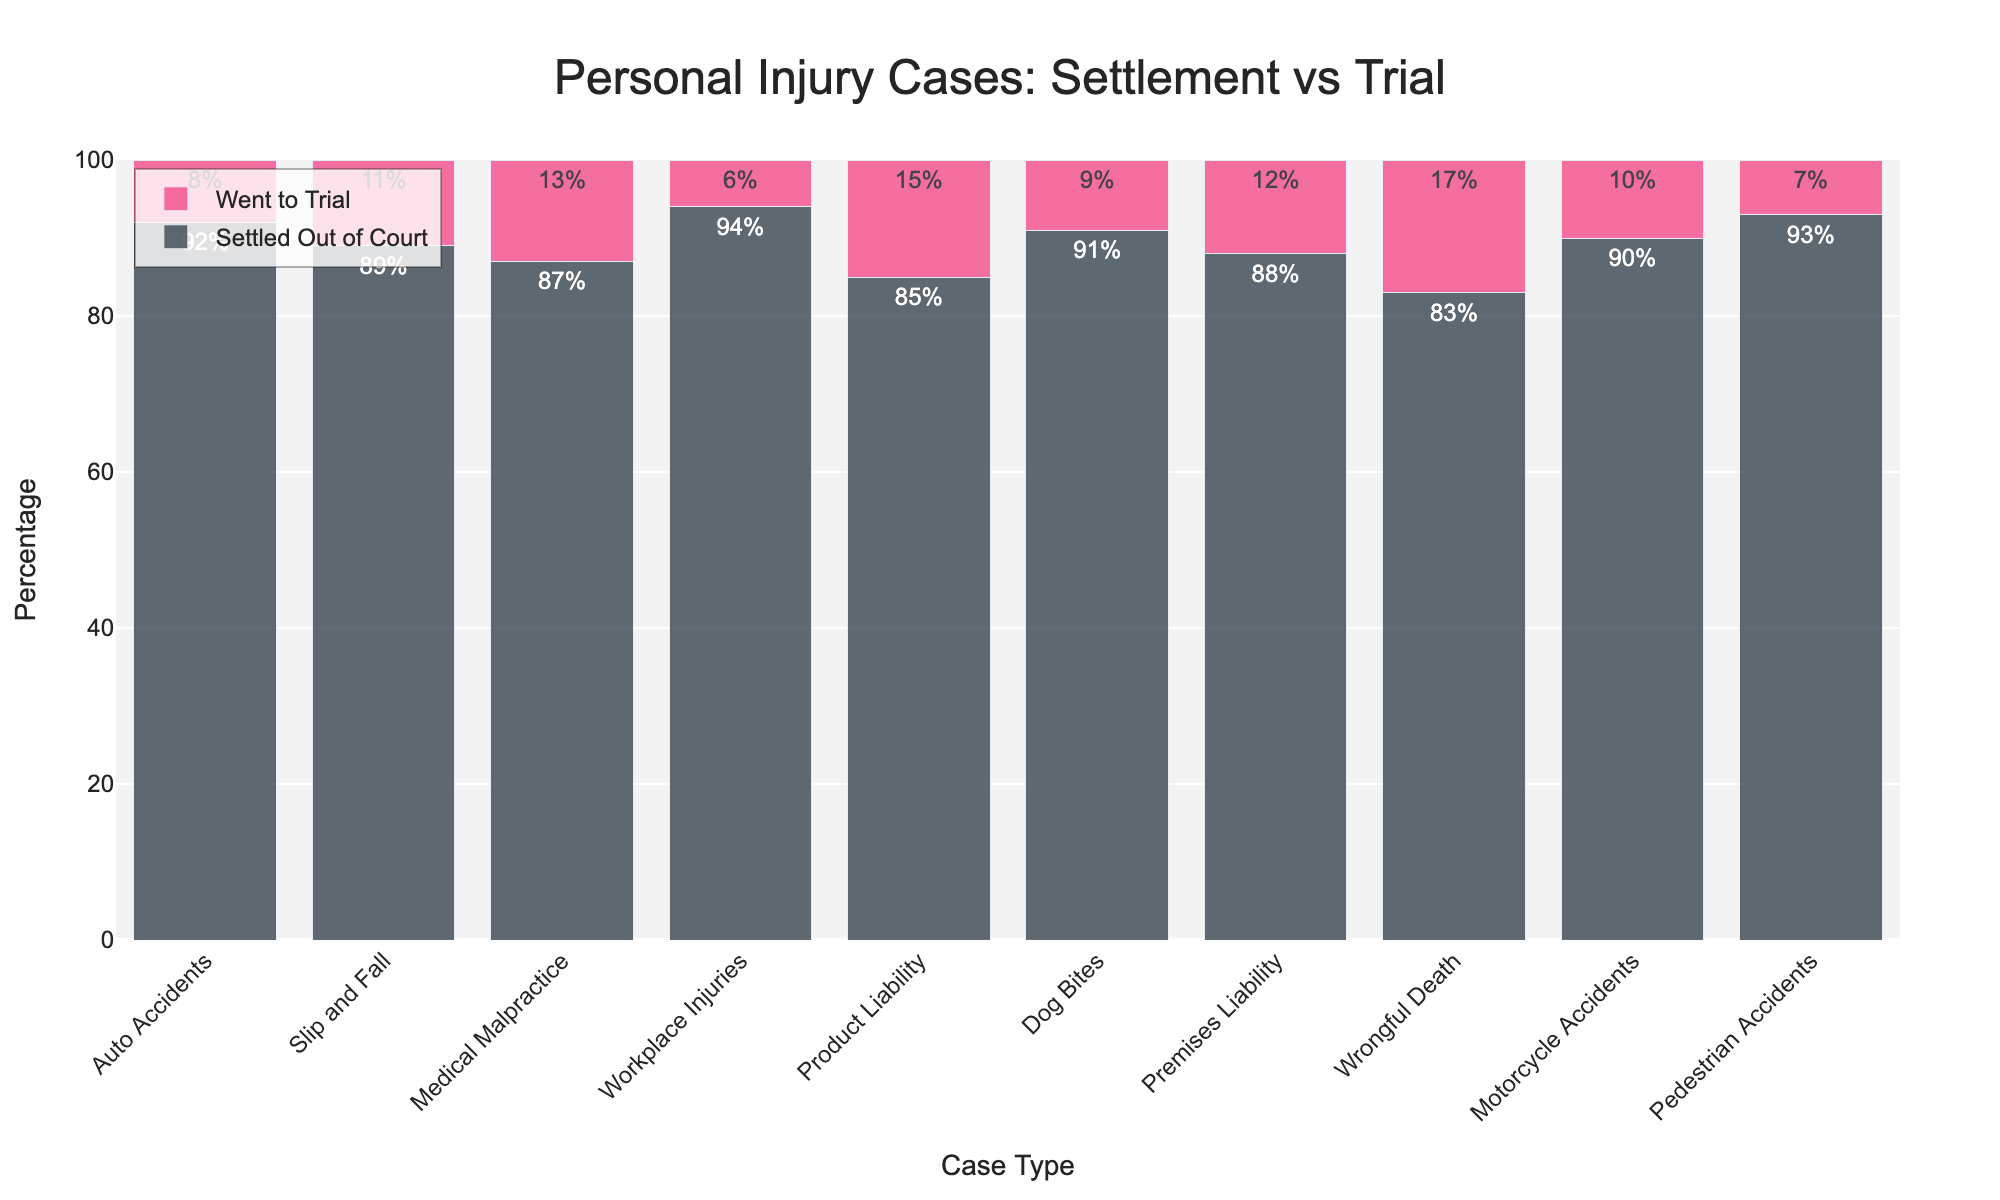Which case type has the highest percentage of cases settled out of court? By looking at the bars representing each case type in the "Settled Out of Court" category, we see that Workplace Injuries has the tallest bar, indicating the highest percentage.
Answer: Workplace Injuries What is the difference in percentage between cases settled out of court and those that went to trial for Medical Malpractice? For Medical Malpractice, 87% of cases are settled out of court and 13% go to trial. The difference is 87% - 13% = 74%.
Answer: 74% Which case type has the smallest proportion of cases that go to trial? The "Went to Trial" category displays the smallest bar for Workplace Injuries, which means it has the smallest proportion of cases going to trial.
Answer: Workplace Injuries Compare the percentages of cases settled out of court for Dog Bites and Slip and Fall. Which has a higher percentage and by how much? Dog Bites have 91% of cases settled out of court, while Slip and Fall have 89%. The difference is 91% - 89% = 2%. Dog Bites have a higher percentage by 2%.
Answer: Dog Bites by 2% Which two case types have the largest difference in the percentage of cases that went to trial? The largest difference is between Product Liability (15%) and Workplace Injuries (6%). The difference is 15% - 6% = 9%.
Answer: Product Liability and Workplace Injuries Sum the percentages of cases that went to trial for Auto Accidents, Dog Bites, and Motorcycle Accidents. The percentages for cases that went to trial are: Auto Accidents (8%), Dog Bites (9%), and Motorcycle Accidents (10%). Adding them up, 8% + 9% + 10% = 27%.
Answer: 27% Which case type has the closest percentage of cases settled out of court and went to trial? Wrongful Death has 83% of cases settled out of court and 17% going to trial, which are the closest in percentage compared to other case types.
Answer: Wrongful Death How do the lengths of bars compare visually between Pedestrian Accidents and Medical Malpractice for cases that went to trial? The bar for Pedestrian Accidents (7%) in the "Went to Trial" category is shorter than the bar for Medical Malpractice (13%). This indicates that Pedestrian Accidents have a lower percentage of cases going to trial.
Answer: Pedestrian Accidents are shorter Calculate the average percentage of cases that went to trial across all case types. Adding the percentages for each case type that went to trial: (8% + 11% + 13% + 6% + 15% + 9% + 12% + 17% + 10% + 7%) = 108%. Since there are 10 case types, the average is 108% / 10 = 10.8%.
Answer: 10.8% 